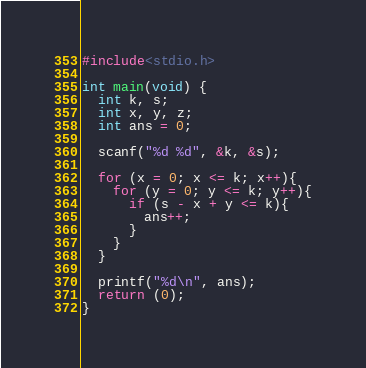Convert code to text. <code><loc_0><loc_0><loc_500><loc_500><_C_>#include<stdio.h>

int main(void) {
  int k, s;
  int x, y, z;
  int ans = 0;

  scanf("%d %d", &k, &s);

  for (x = 0; x <= k; x++){
    for (y = 0; y <= k; y++){
      if (s - x + y <= k){
        ans++;
      }
    }
  }

  printf("%d\n", ans);
  return (0);
}
</code> 